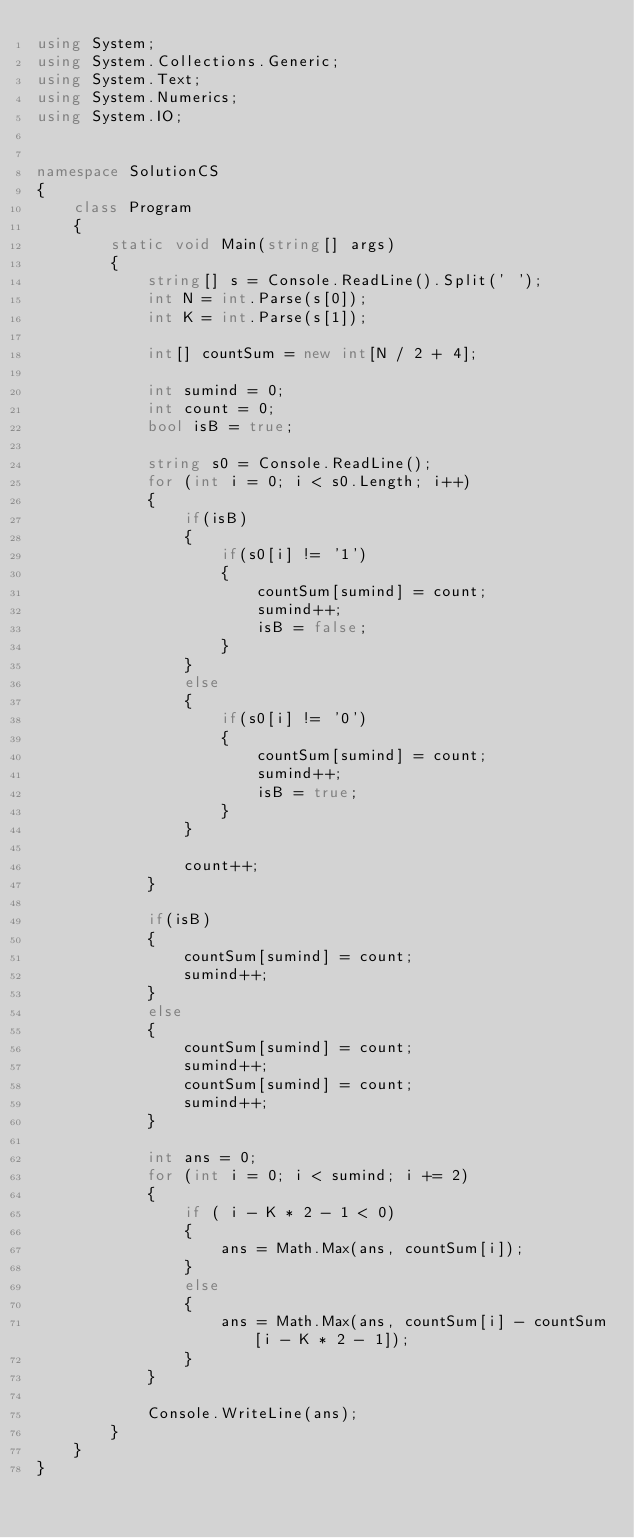<code> <loc_0><loc_0><loc_500><loc_500><_C#_>using System;
using System.Collections.Generic;
using System.Text;
using System.Numerics;
using System.IO;


namespace SolutionCS
{
    class Program
    {
        static void Main(string[] args)
        {
            string[] s = Console.ReadLine().Split(' ');
            int N = int.Parse(s[0]);
            int K = int.Parse(s[1]);

            int[] countSum = new int[N / 2 + 4];

            int sumind = 0;
            int count = 0;
            bool isB = true;

            string s0 = Console.ReadLine();
            for (int i = 0; i < s0.Length; i++)
            {
                if(isB)
                {
                    if(s0[i] != '1')
                    {
                        countSum[sumind] = count;
                        sumind++;
                        isB = false;
                    }
                }
                else
                {
                    if(s0[i] != '0')
                    {
                        countSum[sumind] = count;
                        sumind++;
                        isB = true;
                    }
                }

                count++;
            }

            if(isB)
            {
                countSum[sumind] = count;
                sumind++;
            }
            else
            {
                countSum[sumind] = count;
                sumind++;
                countSum[sumind] = count;
                sumind++;
            }

            int ans = 0;
            for (int i = 0; i < sumind; i += 2)
            {
                if ( i - K * 2 - 1 < 0)
                {
                    ans = Math.Max(ans, countSum[i]);
                }
                else
                {
                    ans = Math.Max(ans, countSum[i] - countSum[i - K * 2 - 1]);
                }
            }

            Console.WriteLine(ans);
        }
    }
}


</code> 